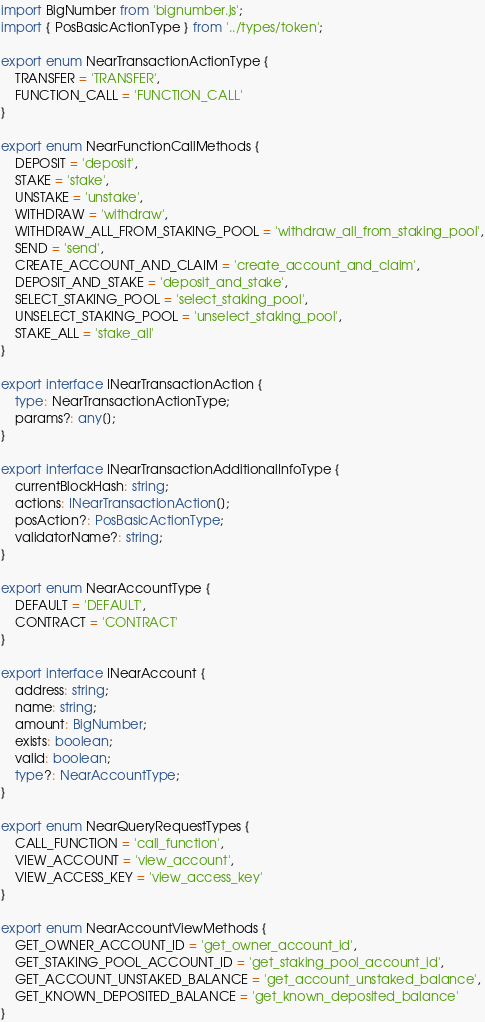<code> <loc_0><loc_0><loc_500><loc_500><_TypeScript_>import BigNumber from 'bignumber.js';
import { PosBasicActionType } from '../types/token';

export enum NearTransactionActionType {
    TRANSFER = 'TRANSFER',
    FUNCTION_CALL = 'FUNCTION_CALL'
}

export enum NearFunctionCallMethods {
    DEPOSIT = 'deposit',
    STAKE = 'stake',
    UNSTAKE = 'unstake',
    WITHDRAW = 'withdraw',
    WITHDRAW_ALL_FROM_STAKING_POOL = 'withdraw_all_from_staking_pool',
    SEND = 'send',
    CREATE_ACCOUNT_AND_CLAIM = 'create_account_and_claim',
    DEPOSIT_AND_STAKE = 'deposit_and_stake',
    SELECT_STAKING_POOL = 'select_staking_pool',
    UNSELECT_STAKING_POOL = 'unselect_staking_pool',
    STAKE_ALL = 'stake_all'
}

export interface INearTransactionAction {
    type: NearTransactionActionType;
    params?: any[];
}

export interface INearTransactionAdditionalInfoType {
    currentBlockHash: string;
    actions: INearTransactionAction[];
    posAction?: PosBasicActionType;
    validatorName?: string;
}

export enum NearAccountType {
    DEFAULT = 'DEFAULT',
    CONTRACT = 'CONTRACT'
}

export interface INearAccount {
    address: string;
    name: string;
    amount: BigNumber;
    exists: boolean;
    valid: boolean;
    type?: NearAccountType;
}

export enum NearQueryRequestTypes {
    CALL_FUNCTION = 'call_function',
    VIEW_ACCOUNT = 'view_account',
    VIEW_ACCESS_KEY = 'view_access_key'
}

export enum NearAccountViewMethods {
    GET_OWNER_ACCOUNT_ID = 'get_owner_account_id',
    GET_STAKING_POOL_ACCOUNT_ID = 'get_staking_pool_account_id',
    GET_ACCOUNT_UNSTAKED_BALANCE = 'get_account_unstaked_balance',
    GET_KNOWN_DEPOSITED_BALANCE = 'get_known_deposited_balance'
}
</code> 